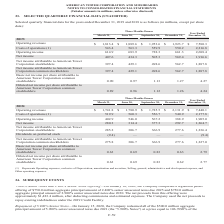According to American Tower Corporation's financial document, What was the operating revenue in Three Months Ended  June? According to the financial document, $1,889.6 (in millions). The relevant text states: "2019: Operating revenues $ 1,813.4 $ 1,889.6 $ 1,953.6 $ 1,923.7 $ 7,580.3..." Also, What was the operating income in Three Months Ended  March? According to the financial document, 614.9 (in millions). The relevant text states: "543.4 563.3 559.9 550.2 2,216.8 Operating income 614.9 683.9 728.3 661.3 2,688.4..." Also, What was the Basic net income per share attributable to American Tower Corporation common stockholders in Three Months Ended  September? According to the financial document, 1.13. The relevant text states: "n Tower Corporation common stockholders 0.90 0.97 1.13 1.27 4.27..." Also, can you calculate: What was the change in Diluted net income per share attributable to American Tower Corporation common stockholders between Three Months Ended  March and June? Based on the calculation: 0.96-0.89, the result is 0.07. This is based on the information: "to American Tower Corporation common stockholders 0.89 0.96 1.12 1.26 4.24 erican Tower Corporation common stockholders 0.89 0.96 1.12 1.26 4.24..." The key data points involved are: 0.89, 0.96. Also, can you calculate: What was the change in net income between Three Months Ended  June and September? Based on the calculation: 505.3-434.3, the result is 71 (in millions). This is based on the information: "Net income 407.6 434.3 505.3 569.4 1,916.6 Net income 407.6 434.3 505.3 569.4 1,916.6..." The key data points involved are: 434.3, 505.3. Also, can you calculate: What was the percentage change in operating revenues between Three Months Ended  September and December? To answer this question, I need to perform calculations using the financial data. The calculation is: ($1,923.7-$1,953.6)/$1,953.6, which equals -1.53 (percentage). This is based on the information: "perating revenues $ 1,813.4 $ 1,889.6 $ 1,953.6 $ 1,923.7 $ 7,580.3 2019: Operating revenues $ 1,813.4 $ 1,889.6 $ 1,953.6 $ 1,923.7 $ 7,580.3..." The key data points involved are: 1,923.7, 1,953.6. 